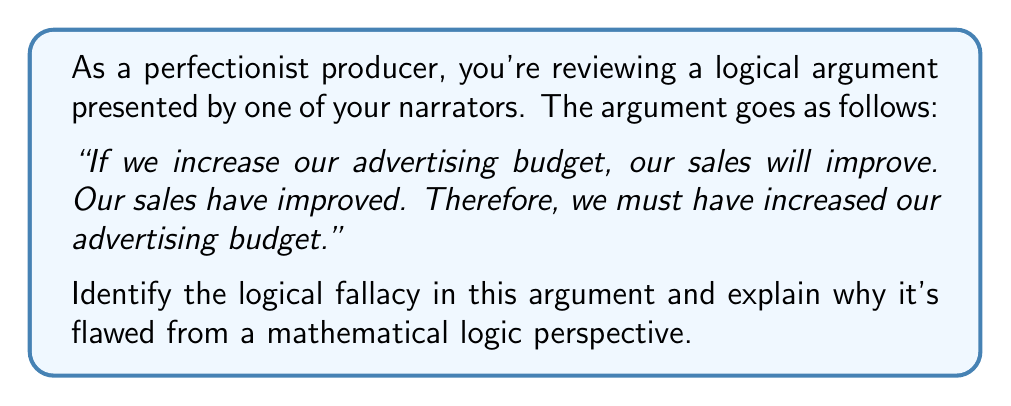Teach me how to tackle this problem. To analyze this argument from a mathematical logic perspective, let's break it down into its component parts:

1. Let $p$ represent "We increase our advertising budget"
2. Let $q$ represent "Our sales will improve"

The argument can be represented as:

1. $p \implies q$ (If we increase our advertising budget, our sales will improve)
2. $q$ (Our sales have improved)
3. Therefore, $p$ (We must have increased our advertising budget)

This argument follows the structure:

$$(p \implies q) \land q \therefore p$$

This is a classic example of the logical fallacy known as "affirming the consequent" or "converse error."

In propositional logic, the statement $p \implies q$ is not equivalent to its converse $q \implies p$. The original implication only states that $q$ is a necessary condition of $p$, not a sufficient one.

To illustrate why this is fallacious, consider the truth table for $p \implies q$:

$$
\begin{array}{|c|c|c|}
\hline
p & q & p \implies q \\
\hline
T & T & T \\
T & F & F \\
F & T & T \\
F & F & T \\
\hline
\end{array}
$$

As we can see, when $q$ is true, $p$ can be either true or false while still maintaining a true implication. Therefore, knowing that $q$ is true does not allow us to conclude that $p$ must be true.

In the context of the argument, there could be other factors that led to improved sales, such as:
- Economic growth
- Improved product quality
- Increased demand in the market

By assuming that increased advertising budget is the only possible cause for improved sales, the argument commits the logical fallacy of affirming the consequent.
Answer: The logical fallacy in this argument is "affirming the consequent" or "converse error." It incorrectly assumes that if the consequent (improved sales) is true, then the antecedent (increased advertising budget) must also be true, which is not a valid logical inference. 